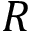<formula> <loc_0><loc_0><loc_500><loc_500>R</formula> 